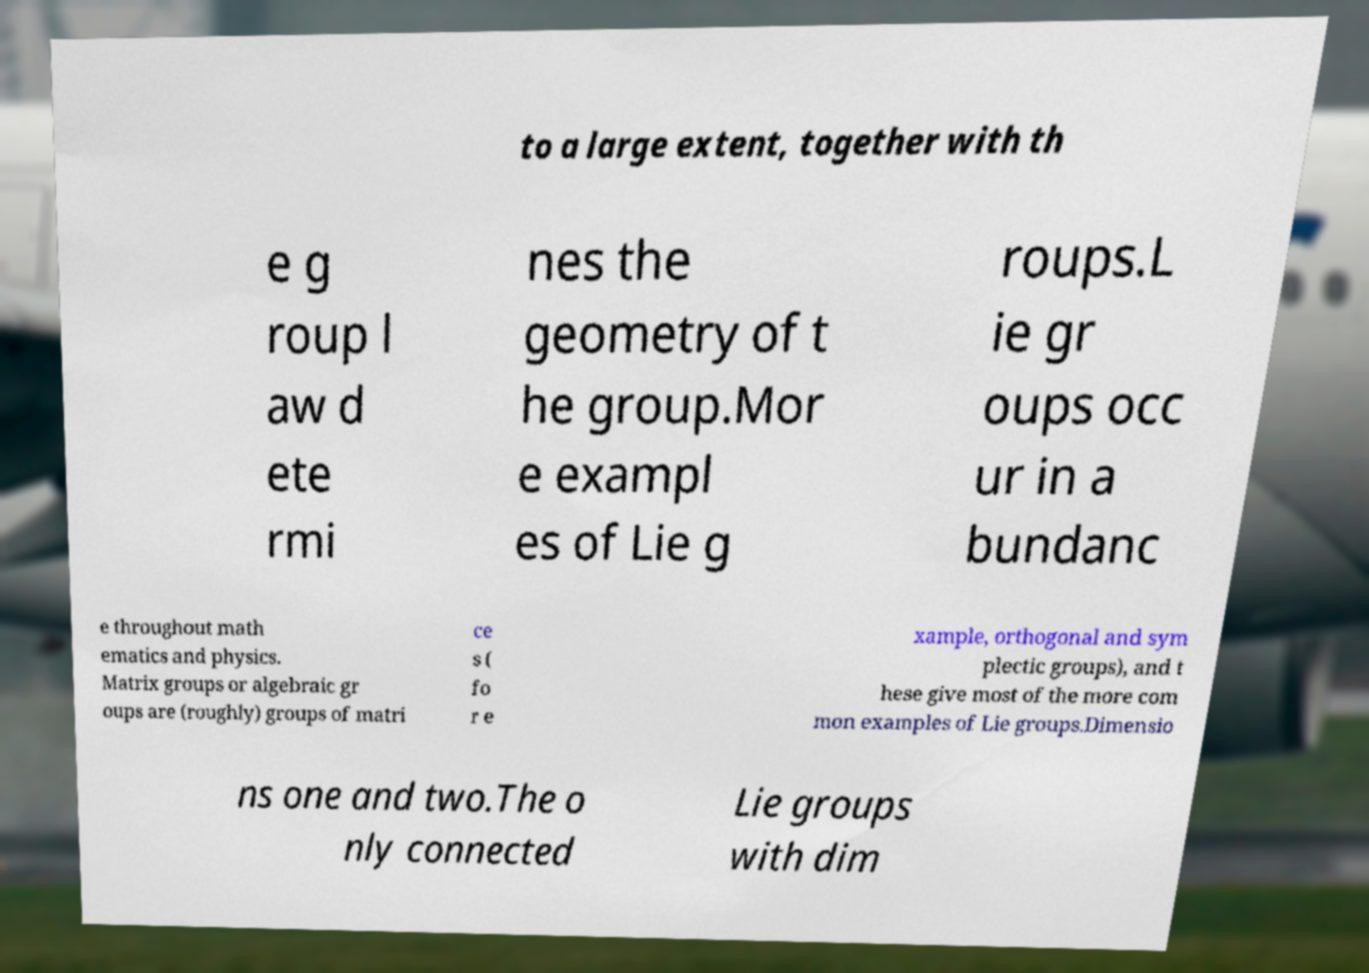Could you assist in decoding the text presented in this image and type it out clearly? to a large extent, together with th e g roup l aw d ete rmi nes the geometry of t he group.Mor e exampl es of Lie g roups.L ie gr oups occ ur in a bundanc e throughout math ematics and physics. Matrix groups or algebraic gr oups are (roughly) groups of matri ce s ( fo r e xample, orthogonal and sym plectic groups), and t hese give most of the more com mon examples of Lie groups.Dimensio ns one and two.The o nly connected Lie groups with dim 